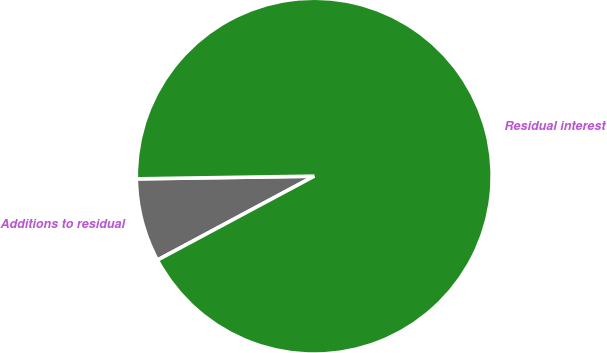Convert chart. <chart><loc_0><loc_0><loc_500><loc_500><pie_chart><fcel>Additions to residual<fcel>Residual interest<nl><fcel>7.58%<fcel>92.42%<nl></chart> 